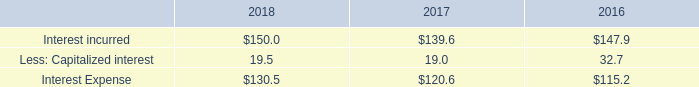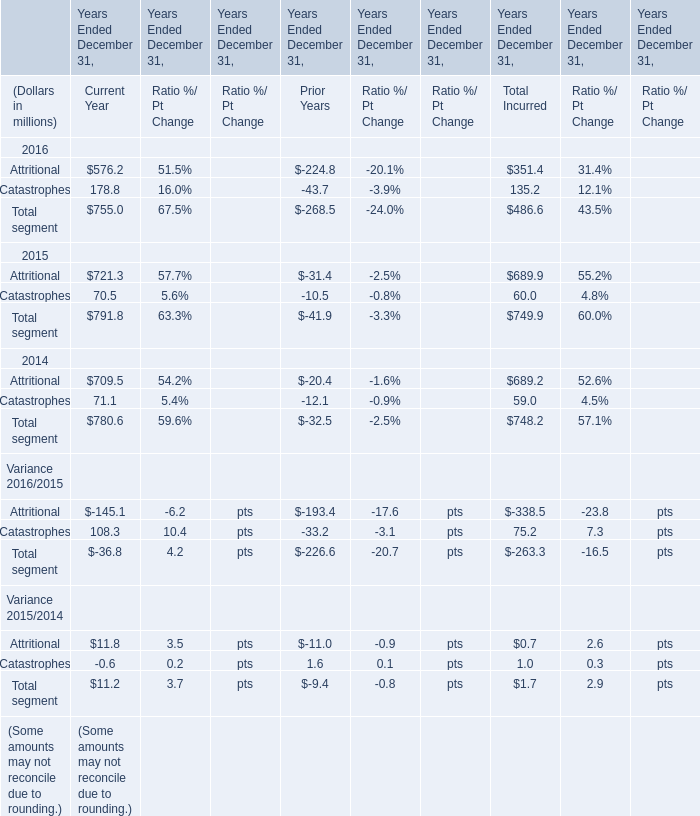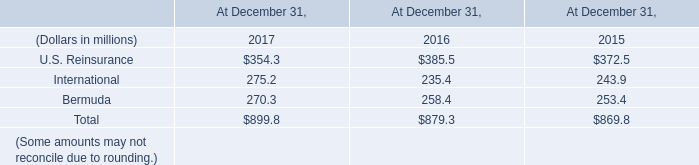In the year with lowest amount of Catastrophes, what's the increasing rate of Total segment? (in %) 
Computations: ((791.8 - 780.6) / 780.6)
Answer: 0.01435. 